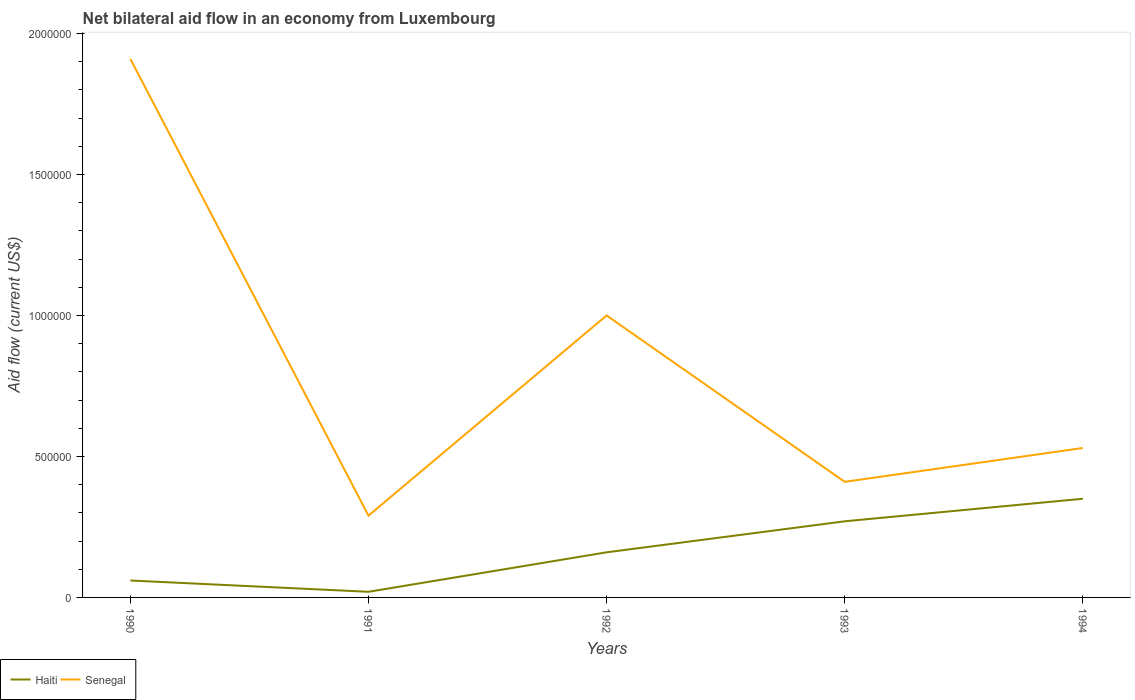Does the line corresponding to Senegal intersect with the line corresponding to Haiti?
Your answer should be very brief. No. Is the number of lines equal to the number of legend labels?
Give a very brief answer. Yes. Across all years, what is the maximum net bilateral aid flow in Haiti?
Offer a terse response. 2.00e+04. In which year was the net bilateral aid flow in Senegal maximum?
Make the answer very short. 1991. What is the total net bilateral aid flow in Senegal in the graph?
Give a very brief answer. 9.10e+05. What is the difference between the highest and the second highest net bilateral aid flow in Senegal?
Ensure brevity in your answer.  1.62e+06. How many lines are there?
Your response must be concise. 2. How many years are there in the graph?
Your answer should be compact. 5. What is the difference between two consecutive major ticks on the Y-axis?
Your answer should be very brief. 5.00e+05. Are the values on the major ticks of Y-axis written in scientific E-notation?
Provide a succinct answer. No. Does the graph contain any zero values?
Provide a short and direct response. No. What is the title of the graph?
Keep it short and to the point. Net bilateral aid flow in an economy from Luxembourg. Does "Algeria" appear as one of the legend labels in the graph?
Offer a very short reply. No. What is the label or title of the X-axis?
Give a very brief answer. Years. What is the label or title of the Y-axis?
Your answer should be compact. Aid flow (current US$). What is the Aid flow (current US$) in Senegal in 1990?
Keep it short and to the point. 1.91e+06. What is the Aid flow (current US$) of Haiti in 1991?
Provide a short and direct response. 2.00e+04. What is the Aid flow (current US$) of Senegal in 1991?
Offer a terse response. 2.90e+05. What is the Aid flow (current US$) in Haiti in 1992?
Provide a short and direct response. 1.60e+05. What is the Aid flow (current US$) of Senegal in 1992?
Ensure brevity in your answer.  1.00e+06. What is the Aid flow (current US$) of Senegal in 1994?
Give a very brief answer. 5.30e+05. Across all years, what is the maximum Aid flow (current US$) in Senegal?
Your answer should be compact. 1.91e+06. Across all years, what is the minimum Aid flow (current US$) in Haiti?
Keep it short and to the point. 2.00e+04. What is the total Aid flow (current US$) of Haiti in the graph?
Your response must be concise. 8.60e+05. What is the total Aid flow (current US$) in Senegal in the graph?
Your response must be concise. 4.14e+06. What is the difference between the Aid flow (current US$) in Senegal in 1990 and that in 1991?
Make the answer very short. 1.62e+06. What is the difference between the Aid flow (current US$) in Haiti in 1990 and that in 1992?
Give a very brief answer. -1.00e+05. What is the difference between the Aid flow (current US$) in Senegal in 1990 and that in 1992?
Your response must be concise. 9.10e+05. What is the difference between the Aid flow (current US$) of Senegal in 1990 and that in 1993?
Provide a succinct answer. 1.50e+06. What is the difference between the Aid flow (current US$) of Haiti in 1990 and that in 1994?
Your answer should be compact. -2.90e+05. What is the difference between the Aid flow (current US$) of Senegal in 1990 and that in 1994?
Provide a succinct answer. 1.38e+06. What is the difference between the Aid flow (current US$) of Haiti in 1991 and that in 1992?
Your answer should be compact. -1.40e+05. What is the difference between the Aid flow (current US$) in Senegal in 1991 and that in 1992?
Your response must be concise. -7.10e+05. What is the difference between the Aid flow (current US$) in Haiti in 1991 and that in 1993?
Your answer should be very brief. -2.50e+05. What is the difference between the Aid flow (current US$) in Haiti in 1991 and that in 1994?
Your response must be concise. -3.30e+05. What is the difference between the Aid flow (current US$) in Senegal in 1991 and that in 1994?
Provide a succinct answer. -2.40e+05. What is the difference between the Aid flow (current US$) of Haiti in 1992 and that in 1993?
Make the answer very short. -1.10e+05. What is the difference between the Aid flow (current US$) in Senegal in 1992 and that in 1993?
Your answer should be very brief. 5.90e+05. What is the difference between the Aid flow (current US$) of Haiti in 1992 and that in 1994?
Offer a terse response. -1.90e+05. What is the difference between the Aid flow (current US$) of Senegal in 1992 and that in 1994?
Make the answer very short. 4.70e+05. What is the difference between the Aid flow (current US$) in Haiti in 1990 and the Aid flow (current US$) in Senegal in 1992?
Provide a short and direct response. -9.40e+05. What is the difference between the Aid flow (current US$) of Haiti in 1990 and the Aid flow (current US$) of Senegal in 1993?
Your response must be concise. -3.50e+05. What is the difference between the Aid flow (current US$) in Haiti in 1990 and the Aid flow (current US$) in Senegal in 1994?
Your answer should be very brief. -4.70e+05. What is the difference between the Aid flow (current US$) in Haiti in 1991 and the Aid flow (current US$) in Senegal in 1992?
Provide a short and direct response. -9.80e+05. What is the difference between the Aid flow (current US$) in Haiti in 1991 and the Aid flow (current US$) in Senegal in 1993?
Ensure brevity in your answer.  -3.90e+05. What is the difference between the Aid flow (current US$) in Haiti in 1991 and the Aid flow (current US$) in Senegal in 1994?
Your answer should be very brief. -5.10e+05. What is the difference between the Aid flow (current US$) in Haiti in 1992 and the Aid flow (current US$) in Senegal in 1993?
Offer a terse response. -2.50e+05. What is the difference between the Aid flow (current US$) in Haiti in 1992 and the Aid flow (current US$) in Senegal in 1994?
Give a very brief answer. -3.70e+05. What is the average Aid flow (current US$) of Haiti per year?
Your answer should be very brief. 1.72e+05. What is the average Aid flow (current US$) in Senegal per year?
Ensure brevity in your answer.  8.28e+05. In the year 1990, what is the difference between the Aid flow (current US$) of Haiti and Aid flow (current US$) of Senegal?
Ensure brevity in your answer.  -1.85e+06. In the year 1992, what is the difference between the Aid flow (current US$) of Haiti and Aid flow (current US$) of Senegal?
Give a very brief answer. -8.40e+05. What is the ratio of the Aid flow (current US$) of Haiti in 1990 to that in 1991?
Make the answer very short. 3. What is the ratio of the Aid flow (current US$) of Senegal in 1990 to that in 1991?
Offer a terse response. 6.59. What is the ratio of the Aid flow (current US$) of Haiti in 1990 to that in 1992?
Offer a very short reply. 0.38. What is the ratio of the Aid flow (current US$) of Senegal in 1990 to that in 1992?
Ensure brevity in your answer.  1.91. What is the ratio of the Aid flow (current US$) of Haiti in 1990 to that in 1993?
Keep it short and to the point. 0.22. What is the ratio of the Aid flow (current US$) in Senegal in 1990 to that in 1993?
Give a very brief answer. 4.66. What is the ratio of the Aid flow (current US$) in Haiti in 1990 to that in 1994?
Offer a terse response. 0.17. What is the ratio of the Aid flow (current US$) in Senegal in 1990 to that in 1994?
Offer a very short reply. 3.6. What is the ratio of the Aid flow (current US$) in Haiti in 1991 to that in 1992?
Your answer should be compact. 0.12. What is the ratio of the Aid flow (current US$) in Senegal in 1991 to that in 1992?
Offer a terse response. 0.29. What is the ratio of the Aid flow (current US$) of Haiti in 1991 to that in 1993?
Give a very brief answer. 0.07. What is the ratio of the Aid flow (current US$) of Senegal in 1991 to that in 1993?
Your response must be concise. 0.71. What is the ratio of the Aid flow (current US$) of Haiti in 1991 to that in 1994?
Your answer should be very brief. 0.06. What is the ratio of the Aid flow (current US$) of Senegal in 1991 to that in 1994?
Provide a succinct answer. 0.55. What is the ratio of the Aid flow (current US$) in Haiti in 1992 to that in 1993?
Make the answer very short. 0.59. What is the ratio of the Aid flow (current US$) of Senegal in 1992 to that in 1993?
Your answer should be compact. 2.44. What is the ratio of the Aid flow (current US$) in Haiti in 1992 to that in 1994?
Give a very brief answer. 0.46. What is the ratio of the Aid flow (current US$) in Senegal in 1992 to that in 1994?
Provide a succinct answer. 1.89. What is the ratio of the Aid flow (current US$) in Haiti in 1993 to that in 1994?
Make the answer very short. 0.77. What is the ratio of the Aid flow (current US$) in Senegal in 1993 to that in 1994?
Offer a very short reply. 0.77. What is the difference between the highest and the second highest Aid flow (current US$) of Senegal?
Provide a short and direct response. 9.10e+05. What is the difference between the highest and the lowest Aid flow (current US$) in Senegal?
Your answer should be compact. 1.62e+06. 